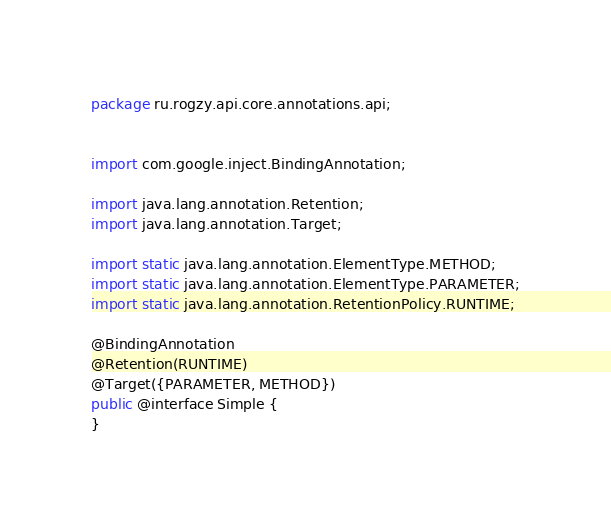<code> <loc_0><loc_0><loc_500><loc_500><_Java_>package ru.rogzy.api.core.annotations.api;


import com.google.inject.BindingAnnotation;

import java.lang.annotation.Retention;
import java.lang.annotation.Target;

import static java.lang.annotation.ElementType.METHOD;
import static java.lang.annotation.ElementType.PARAMETER;
import static java.lang.annotation.RetentionPolicy.RUNTIME;

@BindingAnnotation
@Retention(RUNTIME)
@Target({PARAMETER, METHOD})
public @interface Simple {
}
</code> 